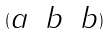Convert formula to latex. <formula><loc_0><loc_0><loc_500><loc_500>( \begin{matrix} a & b & b \end{matrix} )</formula> 